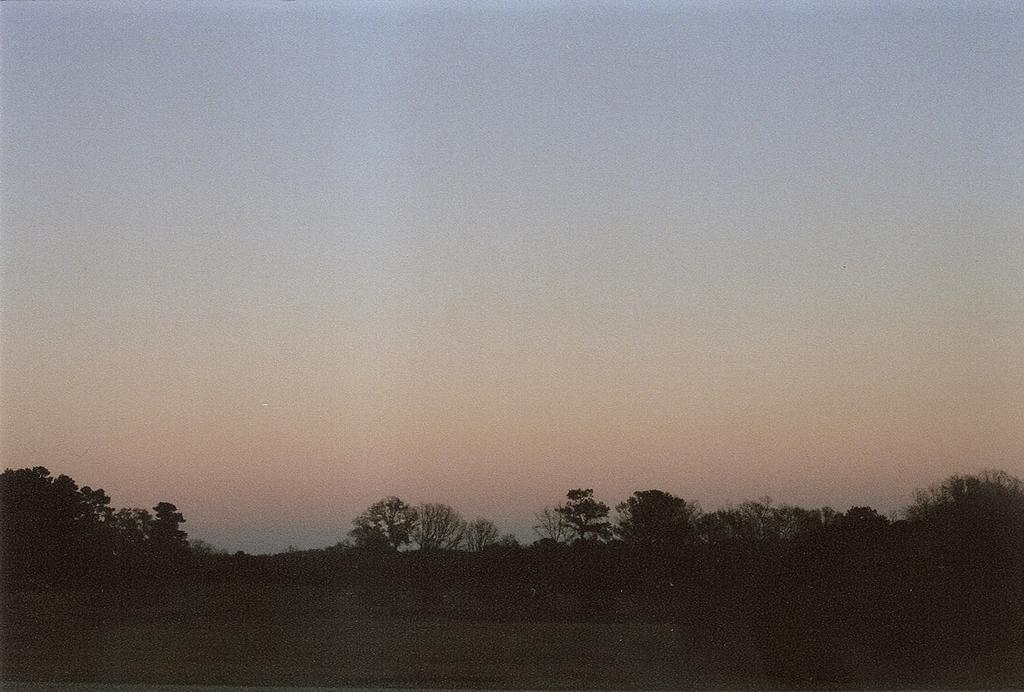What type of vegetation is at the bottom of the image? There are trees at the bottom of the image. What part of the natural environment is visible at the top of the image? The sky is visible at the top of the image. What is the color of the sky in the image? The color of the sky is blue. What type of pen is visible in the image? There is no pen present in the image. What is the reaction of the eye to the blue sky in the image? There is no eye present in the image, so it is not possible to determine a reaction to the blue sky. 